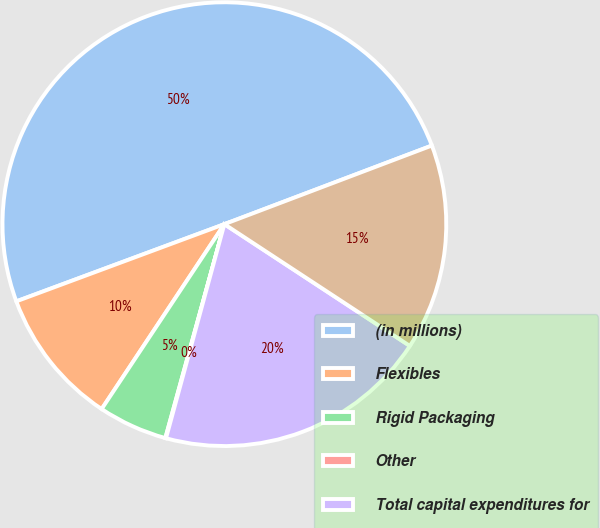Convert chart. <chart><loc_0><loc_0><loc_500><loc_500><pie_chart><fcel>(in millions)<fcel>Flexibles<fcel>Rigid Packaging<fcel>Other<fcel>Total capital expenditures for<fcel>Total depreciation and<nl><fcel>49.89%<fcel>10.02%<fcel>5.04%<fcel>0.05%<fcel>19.99%<fcel>15.01%<nl></chart> 